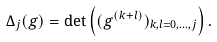Convert formula to latex. <formula><loc_0><loc_0><loc_500><loc_500>\Delta _ { j } ( g ) = \det \left ( ( g ^ { ( k + l ) } ) _ { k , l = 0 , \dots , j } \right ) .</formula> 